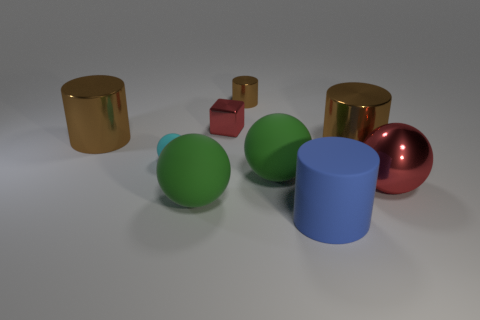What number of objects are either big green objects on the right side of the tiny red object or purple cylinders?
Give a very brief answer. 1. Do the metal cylinder that is to the left of the cyan object and the tiny cylinder have the same color?
Give a very brief answer. Yes. There is a green matte object right of the shiny cube; what size is it?
Your response must be concise. Large. What shape is the brown object that is in front of the large shiny cylinder to the left of the shiny cube?
Ensure brevity in your answer.  Cylinder. There is another matte thing that is the same shape as the tiny brown object; what is its color?
Your response must be concise. Blue. There is a brown cylinder that is to the right of the blue rubber thing; does it have the same size as the tiny cyan rubber sphere?
Keep it short and to the point. No. What shape is the metal thing that is the same color as the big metal ball?
Your answer should be compact. Cube. How many large red objects are the same material as the tiny cylinder?
Offer a very short reply. 1. What material is the green ball that is to the left of the red shiny object that is behind the big cylinder on the left side of the cyan rubber thing?
Give a very brief answer. Rubber. There is a tiny object in front of the large metallic object that is on the left side of the large blue cylinder; what is its color?
Keep it short and to the point. Cyan. 